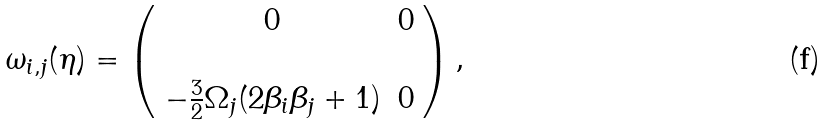Convert formula to latex. <formula><loc_0><loc_0><loc_500><loc_500>\omega _ { i , j } ( \eta ) = \left ( \begin{array} { c c } 0 & 0 \\ \\ - \frac { 3 } { 2 } \Omega _ { j } ( 2 \beta _ { i } \beta _ { j } + 1 ) & 0 \end{array} \right ) ,</formula> 